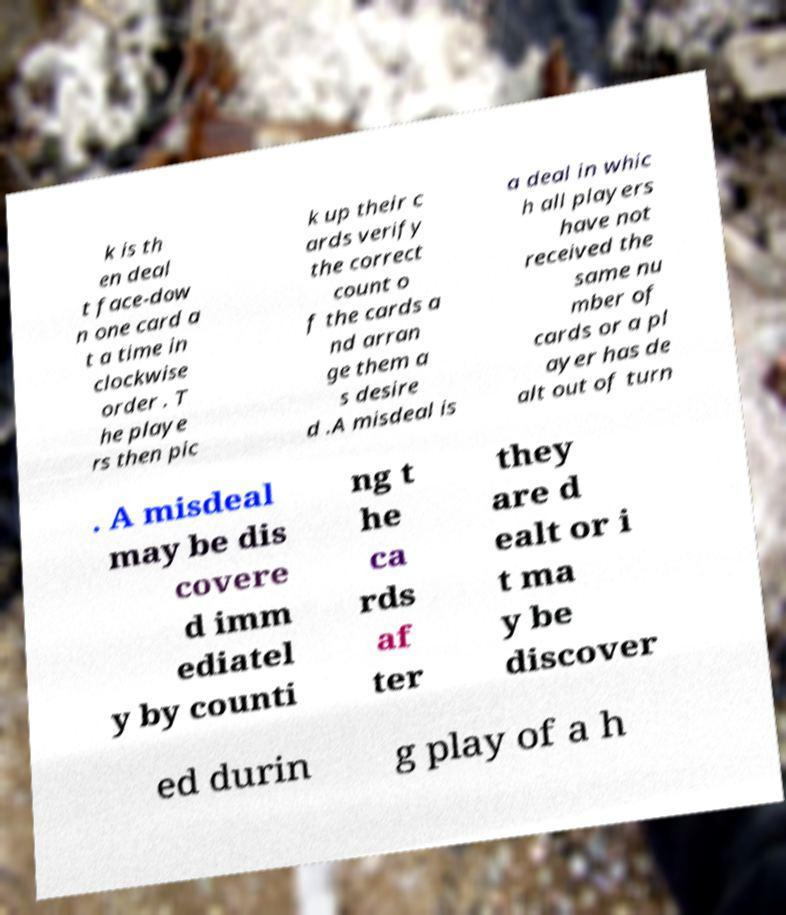What messages or text are displayed in this image? I need them in a readable, typed format. k is th en deal t face-dow n one card a t a time in clockwise order . T he playe rs then pic k up their c ards verify the correct count o f the cards a nd arran ge them a s desire d .A misdeal is a deal in whic h all players have not received the same nu mber of cards or a pl ayer has de alt out of turn . A misdeal may be dis covere d imm ediatel y by counti ng t he ca rds af ter they are d ealt or i t ma y be discover ed durin g play of a h 